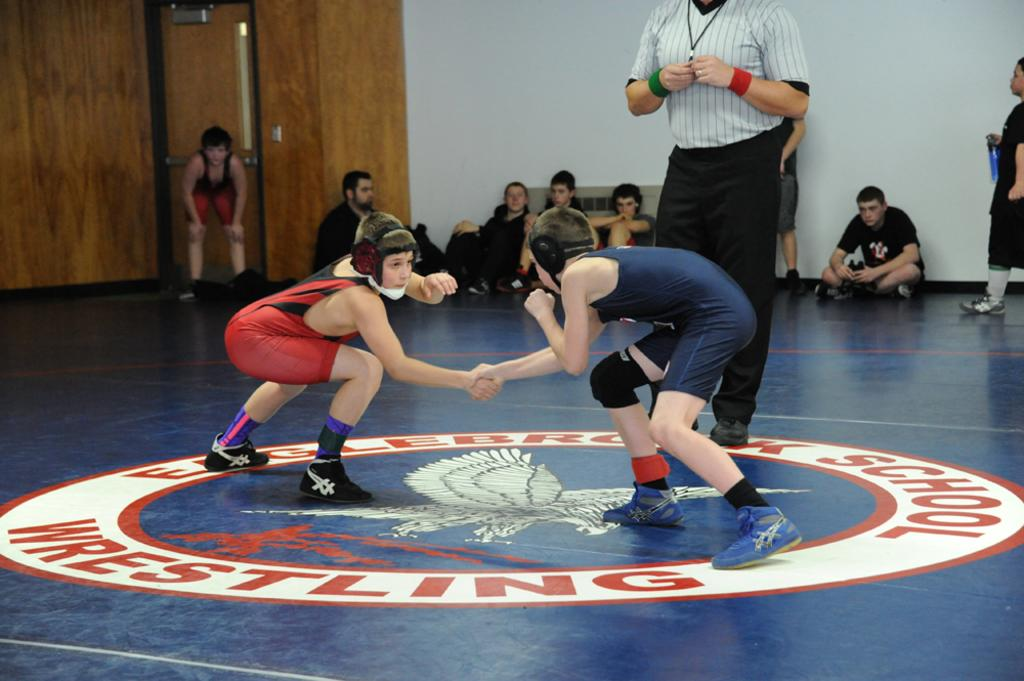<image>
Describe the image concisely. Two wrestlers compete at Eaglebrook School in a match. 